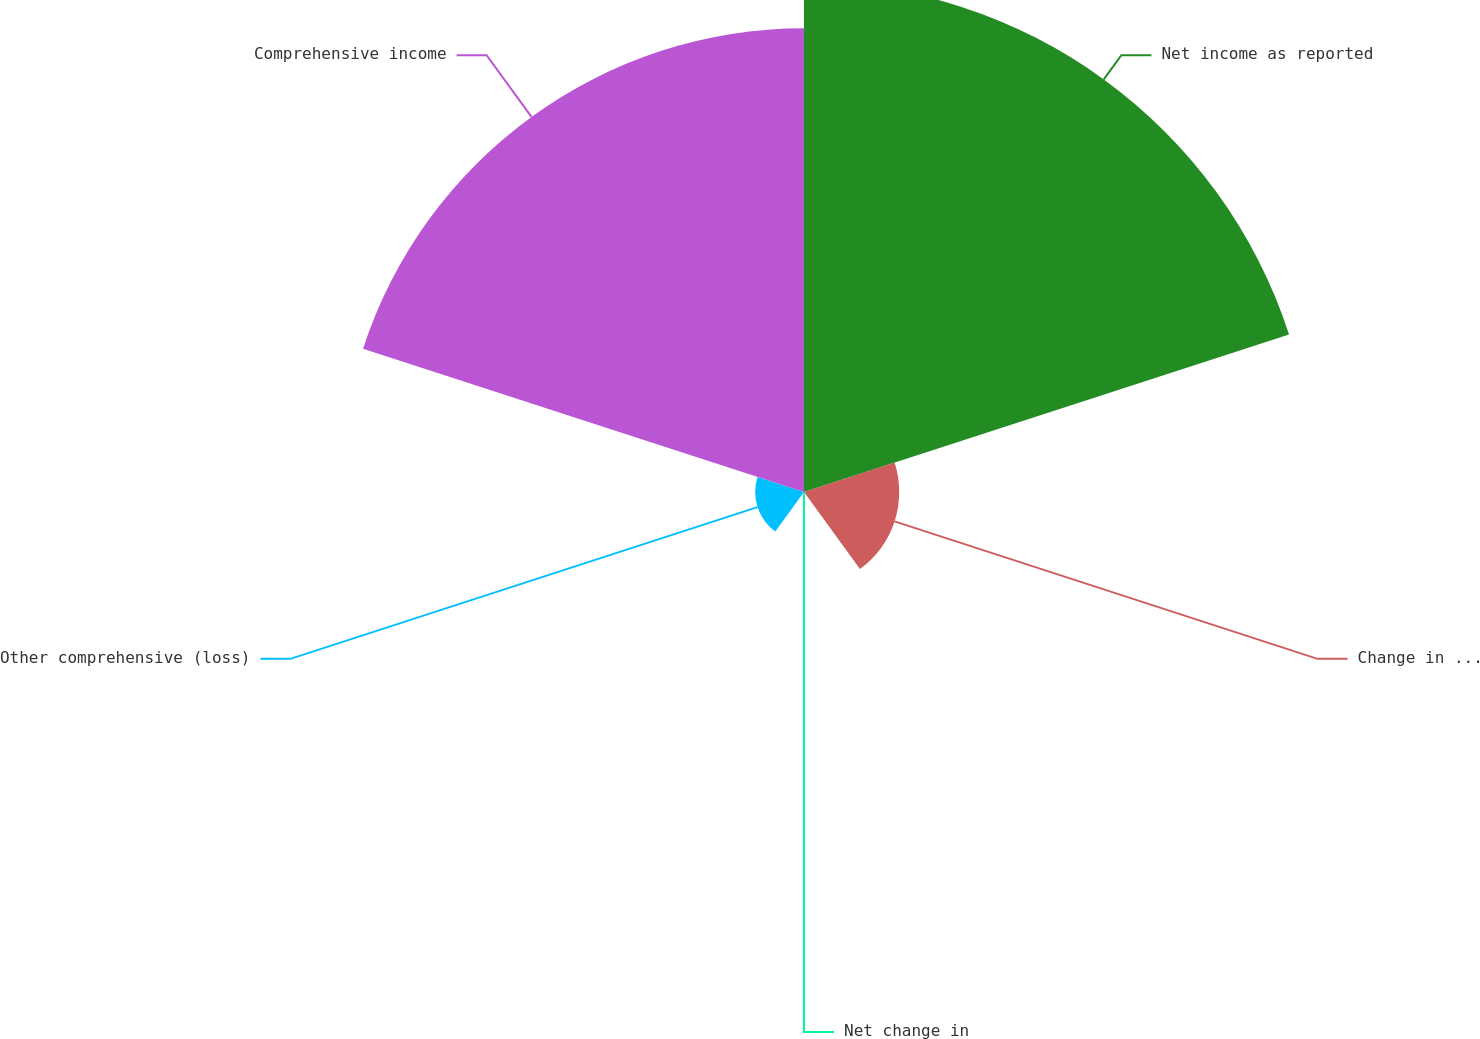Convert chart to OTSL. <chart><loc_0><loc_0><loc_500><loc_500><pie_chart><fcel>Net income as reported<fcel>Change in foreign currency<fcel>Net change in<fcel>Other comprehensive (loss)<fcel>Comprehensive income<nl><fcel>45.53%<fcel>8.5%<fcel>0.22%<fcel>4.36%<fcel>41.39%<nl></chart> 